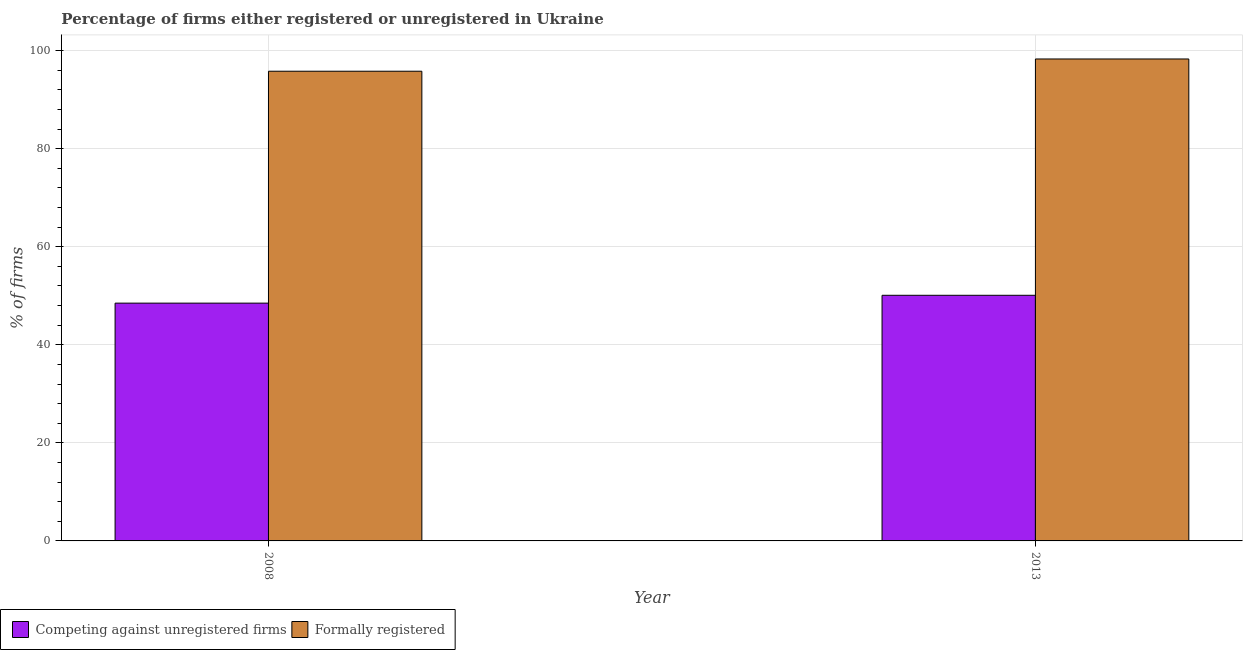How many groups of bars are there?
Give a very brief answer. 2. Are the number of bars per tick equal to the number of legend labels?
Ensure brevity in your answer.  Yes. How many bars are there on the 2nd tick from the left?
Keep it short and to the point. 2. What is the percentage of formally registered firms in 2008?
Offer a terse response. 95.8. Across all years, what is the maximum percentage of registered firms?
Ensure brevity in your answer.  50.1. Across all years, what is the minimum percentage of registered firms?
Offer a terse response. 48.5. What is the total percentage of registered firms in the graph?
Provide a short and direct response. 98.6. What is the average percentage of registered firms per year?
Your answer should be very brief. 49.3. What is the ratio of the percentage of registered firms in 2008 to that in 2013?
Provide a succinct answer. 0.97. Is the percentage of formally registered firms in 2008 less than that in 2013?
Offer a terse response. Yes. In how many years, is the percentage of registered firms greater than the average percentage of registered firms taken over all years?
Make the answer very short. 1. What does the 1st bar from the left in 2013 represents?
Your response must be concise. Competing against unregistered firms. What does the 2nd bar from the right in 2008 represents?
Provide a succinct answer. Competing against unregistered firms. How many bars are there?
Your response must be concise. 4. Are all the bars in the graph horizontal?
Give a very brief answer. No. Are the values on the major ticks of Y-axis written in scientific E-notation?
Give a very brief answer. No. Does the graph contain any zero values?
Your answer should be very brief. No. What is the title of the graph?
Offer a very short reply. Percentage of firms either registered or unregistered in Ukraine. Does "Depositors" appear as one of the legend labels in the graph?
Give a very brief answer. No. What is the label or title of the X-axis?
Offer a terse response. Year. What is the label or title of the Y-axis?
Your answer should be very brief. % of firms. What is the % of firms in Competing against unregistered firms in 2008?
Make the answer very short. 48.5. What is the % of firms in Formally registered in 2008?
Provide a short and direct response. 95.8. What is the % of firms of Competing against unregistered firms in 2013?
Your response must be concise. 50.1. What is the % of firms in Formally registered in 2013?
Your answer should be very brief. 98.3. Across all years, what is the maximum % of firms of Competing against unregistered firms?
Provide a succinct answer. 50.1. Across all years, what is the maximum % of firms of Formally registered?
Keep it short and to the point. 98.3. Across all years, what is the minimum % of firms in Competing against unregistered firms?
Provide a succinct answer. 48.5. Across all years, what is the minimum % of firms in Formally registered?
Keep it short and to the point. 95.8. What is the total % of firms of Competing against unregistered firms in the graph?
Provide a succinct answer. 98.6. What is the total % of firms of Formally registered in the graph?
Your answer should be very brief. 194.1. What is the difference between the % of firms in Competing against unregistered firms in 2008 and that in 2013?
Your answer should be compact. -1.6. What is the difference between the % of firms of Formally registered in 2008 and that in 2013?
Offer a very short reply. -2.5. What is the difference between the % of firms of Competing against unregistered firms in 2008 and the % of firms of Formally registered in 2013?
Your answer should be very brief. -49.8. What is the average % of firms in Competing against unregistered firms per year?
Offer a terse response. 49.3. What is the average % of firms of Formally registered per year?
Keep it short and to the point. 97.05. In the year 2008, what is the difference between the % of firms in Competing against unregistered firms and % of firms in Formally registered?
Give a very brief answer. -47.3. In the year 2013, what is the difference between the % of firms in Competing against unregistered firms and % of firms in Formally registered?
Make the answer very short. -48.2. What is the ratio of the % of firms of Competing against unregistered firms in 2008 to that in 2013?
Your answer should be compact. 0.97. What is the ratio of the % of firms of Formally registered in 2008 to that in 2013?
Give a very brief answer. 0.97. What is the difference between the highest and the second highest % of firms of Competing against unregistered firms?
Offer a terse response. 1.6. What is the difference between the highest and the second highest % of firms of Formally registered?
Give a very brief answer. 2.5. What is the difference between the highest and the lowest % of firms of Formally registered?
Your response must be concise. 2.5. 